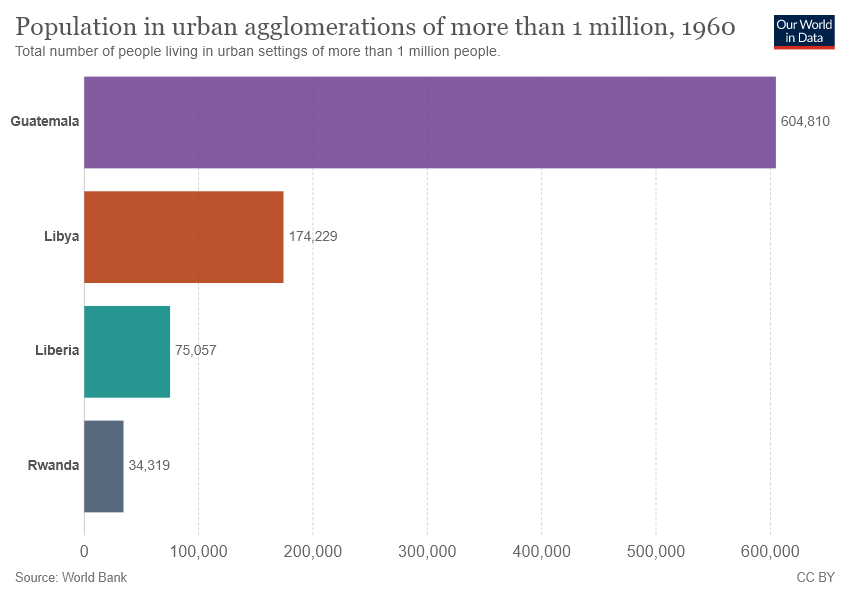Mention a couple of crucial points in this snapshot. The sum of the populations of the three smaller countries is not greater than the population of the largest country. 